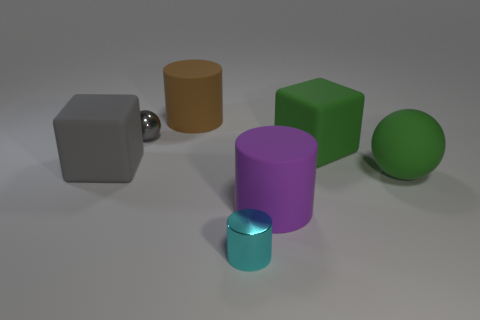Is there any other thing that has the same material as the big green cube?
Keep it short and to the point. Yes. There is a large cylinder that is behind the large green ball; what is its color?
Offer a very short reply. Brown. Are there any green spheres that have the same size as the gray matte thing?
Your response must be concise. Yes. There is a gray cube that is the same size as the purple rubber cylinder; what material is it?
Provide a short and direct response. Rubber. How many objects are cylinders that are in front of the purple object or matte things left of the cyan cylinder?
Ensure brevity in your answer.  3. Are there any cyan metallic things that have the same shape as the gray matte object?
Your response must be concise. No. There is a cube that is the same color as the small sphere; what is it made of?
Offer a very short reply. Rubber. What number of metallic objects are large purple cylinders or large green blocks?
Offer a terse response. 0. The brown matte object has what shape?
Your answer should be very brief. Cylinder. How many tiny objects have the same material as the big brown object?
Your answer should be very brief. 0. 